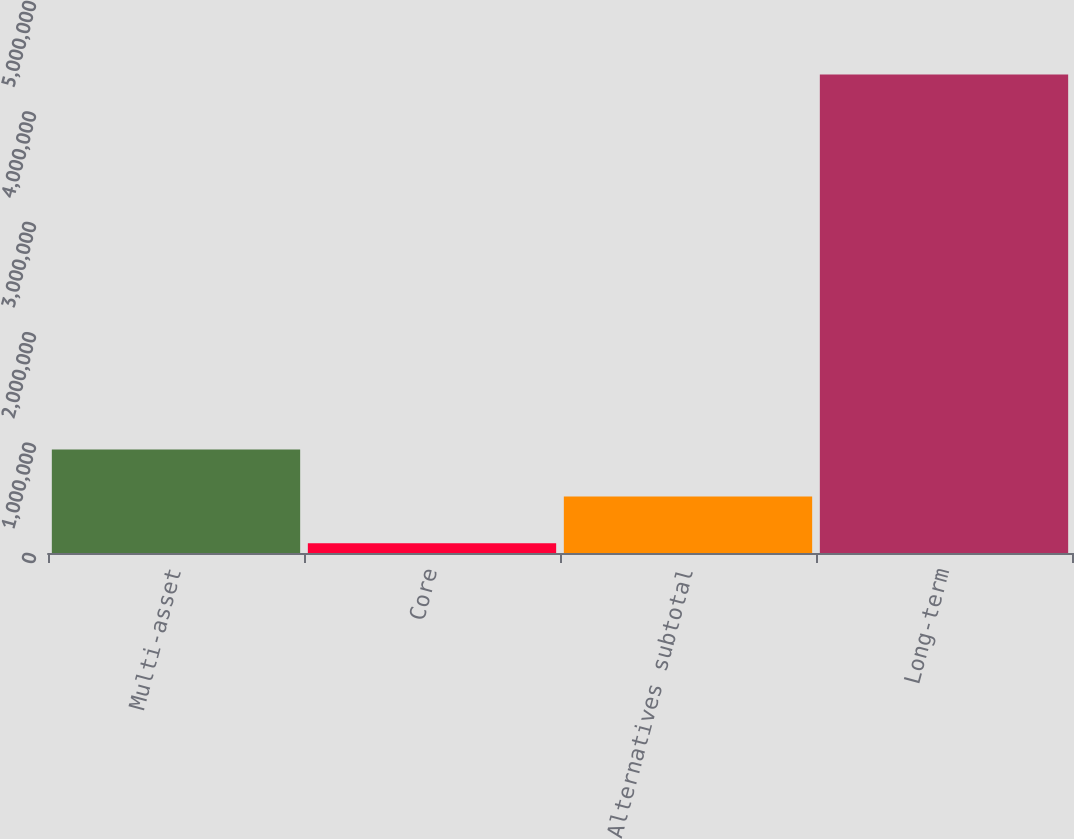Convert chart. <chart><loc_0><loc_0><loc_500><loc_500><bar_chart><fcel>Multi-asset<fcel>Core<fcel>Alternatives subtotal<fcel>Long-term<nl><fcel>937173<fcel>88006<fcel>512590<fcel>4.33384e+06<nl></chart> 